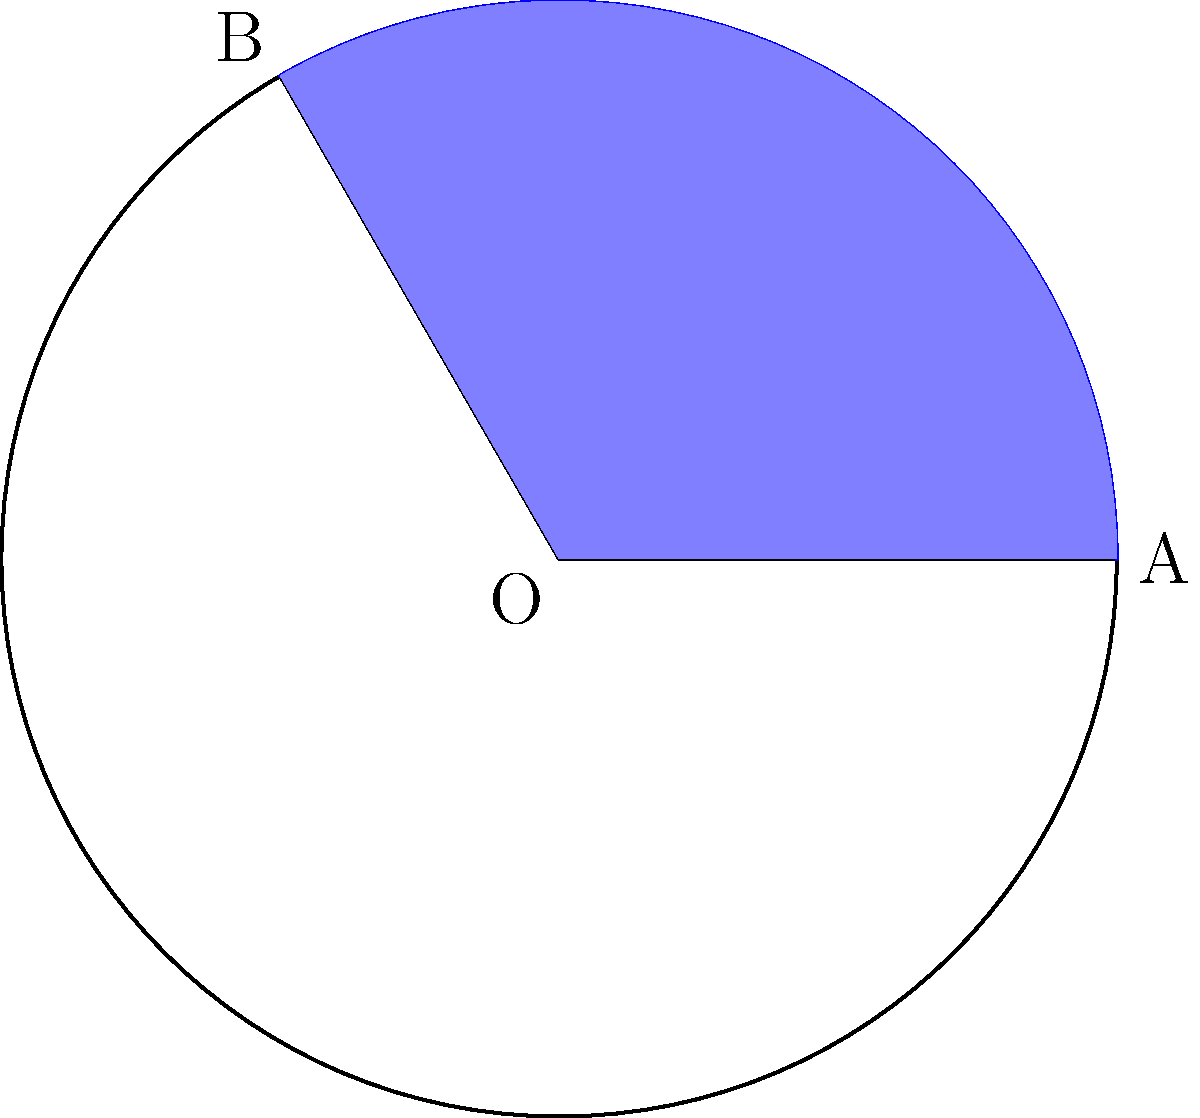In a circular segment, the radius of the circle is 8 meters, and the central angle is 120°. Calculate the area of the circular segment. Round your answer to two decimal places. How might this calculation be relevant in designing curved architectural elements or optimizing space utilization in building layouts? To solve this problem, we'll follow these steps:

1) First, recall the formula for the area of a circular segment:

   $$ A = r^2 \left(\frac{\theta}{2} - \frac{\sin \theta}{2}\right) $$

   where $A$ is the area, $r$ is the radius, and $\theta$ is the central angle in radians.

2) We're given $r = 8$ meters and $\theta = 120°$. We need to convert the angle to radians:

   $$ \theta = 120° \times \frac{\pi}{180°} = \frac{2\pi}{3} \approx 2.0944 \text{ radians} $$

3) Now, let's substitute these values into our formula:

   $$ A = 8^2 \left(\frac{2\pi/3}{2} - \frac{\sin(2\pi/3)}{2}\right) $$

4) Simplify:
   $$ A = 64 \left(\frac{\pi}{3} - \frac{\sqrt{3}}{4}\right) $$

5) Calculate:
   $$ A \approx 64 (1.0472 - 0.4330) = 64 \times 0.6142 \approx 39.3088 \text{ m}^2 $$

6) Rounding to two decimal places:
   $$ A \approx 39.31 \text{ m}^2 $$

This calculation is relevant in architecture for designing curved elements like arched windows or domed ceilings, where understanding the area of circular segments is crucial for material estimation and space optimization. It can also be applied in landscape architecture for circular garden segments or in urban planning for circular plaza sections.
Answer: 39.31 m² 